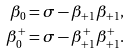<formula> <loc_0><loc_0><loc_500><loc_500>\beta _ { 0 } & = \sigma - \beta _ { + 1 } \beta _ { + 1 } , \\ \beta _ { 0 } ^ { + } & = \sigma - \beta _ { + 1 } ^ { + } \beta _ { + 1 } ^ { + } .</formula> 